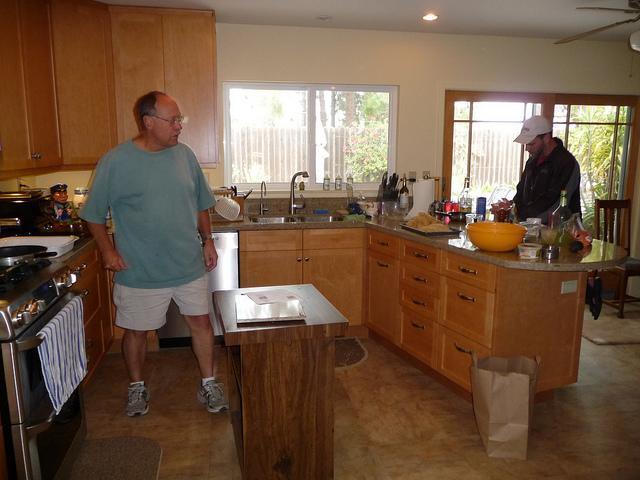How many people are in the photo?
Give a very brief answer. 2. 